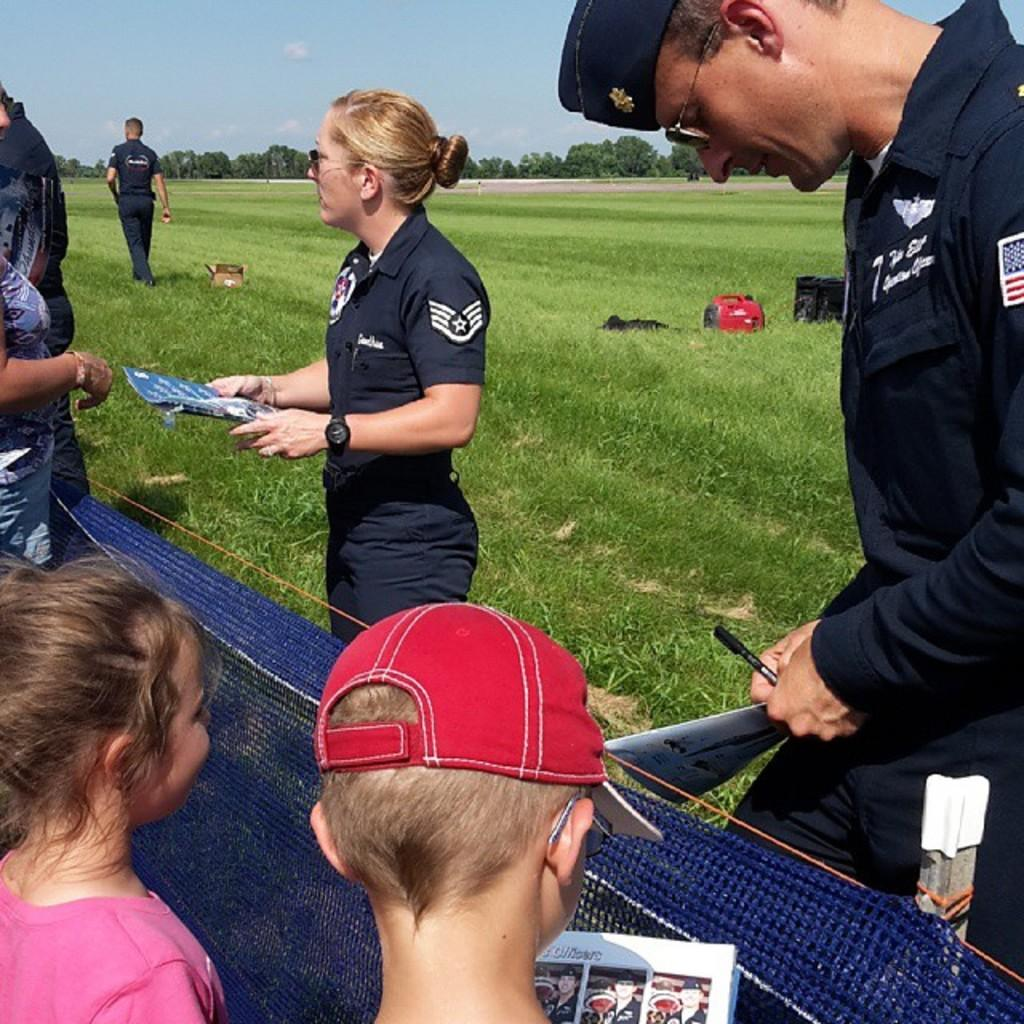What is the general setting of the image? There are people standing on the ground in the image. Can you describe the individuals present in the image? There are men, children, and a woman in the image. What can be seen in the background of the image? There are trees and the sky visible in the background of the image. What type of bell can be heard ringing in the image? There is no bell present or audible in the image. How many knots are tied in the woman's hair in the image? There is no information about the woman's hair or any knots in the image. 